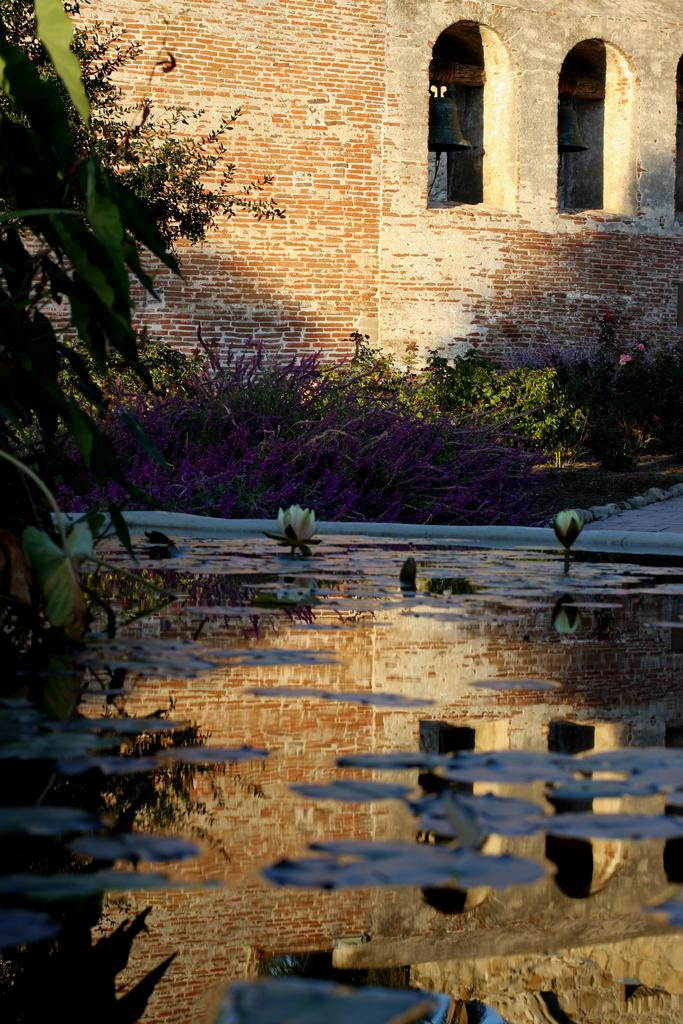What is floating on the water in the image? There are plants and flowers on the water in the image. Can you describe the plant on the left side of the image? There is a plant on the left side of the image. What can be seen in the background of the image? There is a building and two balls hanging from a pole in the background of the image. Are there any other plants visible in the image? Yes, there are plants visible in the background of the image. Where is the camera placed in the image? There is no camera present in the image. What type of table is visible in the image? There is no table present in the image. 